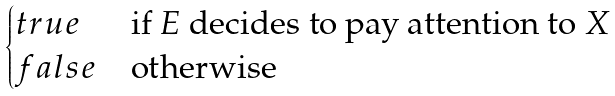<formula> <loc_0><loc_0><loc_500><loc_500>\begin{cases} t r u e & \text {if $E$ decides to pay attention to $X$} \\ f a l s e & \text {otherwise} \end{cases}</formula> 